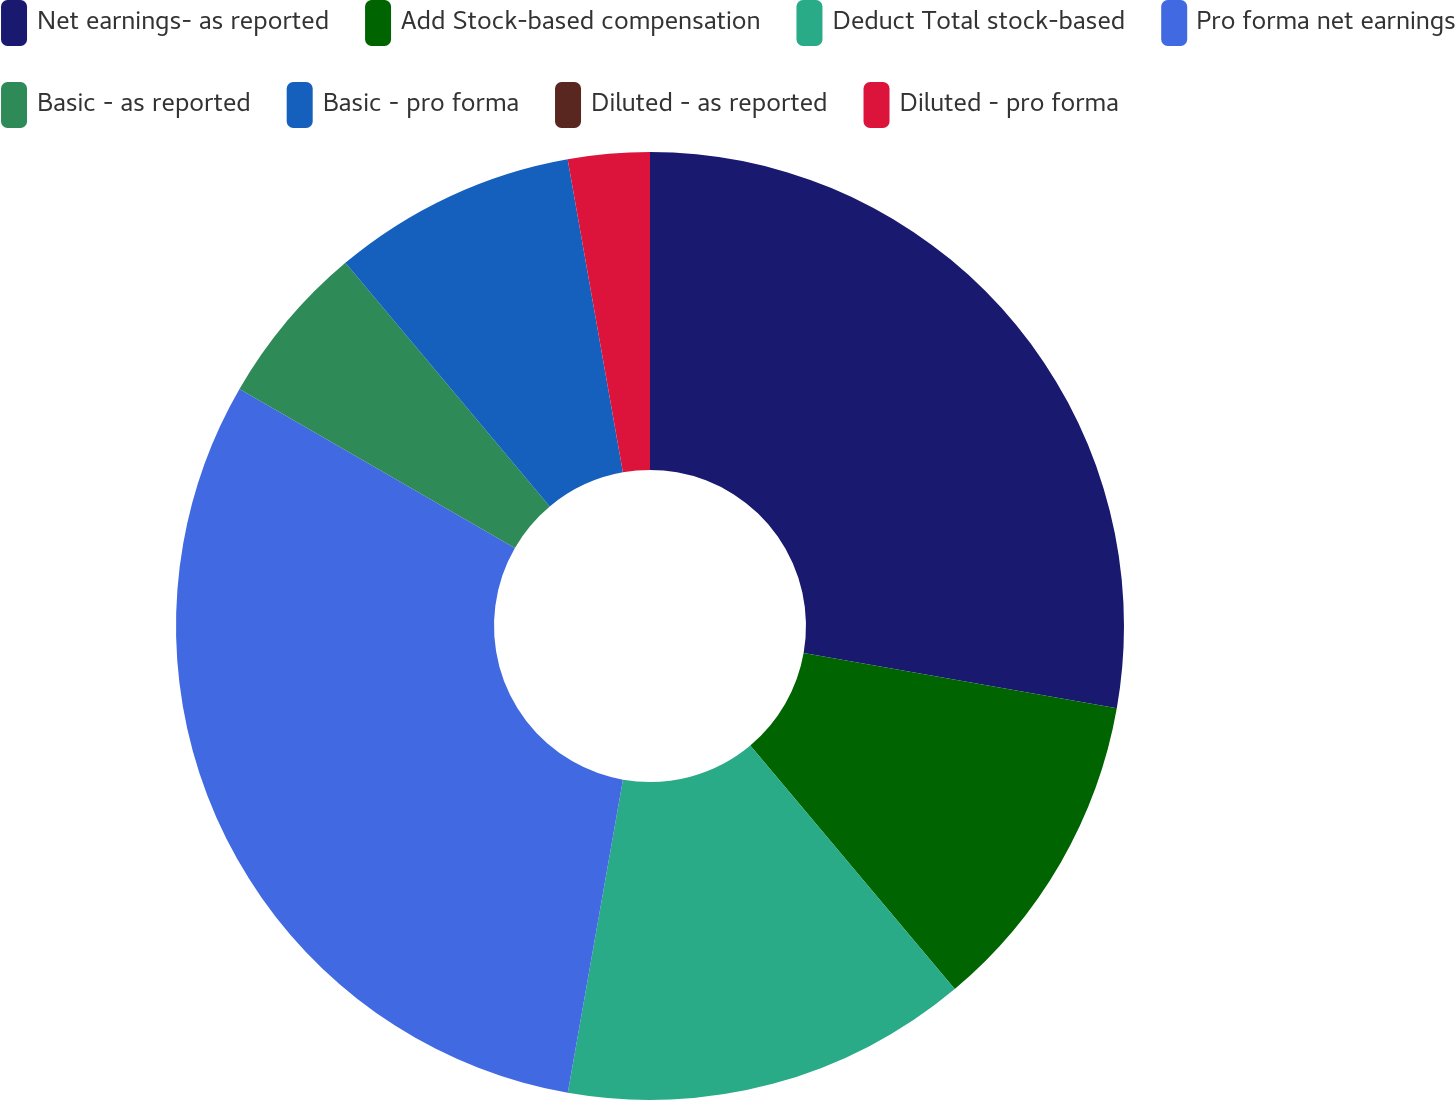<chart> <loc_0><loc_0><loc_500><loc_500><pie_chart><fcel>Net earnings- as reported<fcel>Add Stock-based compensation<fcel>Deduct Total stock-based<fcel>Pro forma net earnings<fcel>Basic - as reported<fcel>Basic - pro forma<fcel>Diluted - as reported<fcel>Diluted - pro forma<nl><fcel>27.78%<fcel>11.11%<fcel>13.89%<fcel>30.56%<fcel>5.56%<fcel>8.33%<fcel>0.0%<fcel>2.78%<nl></chart> 